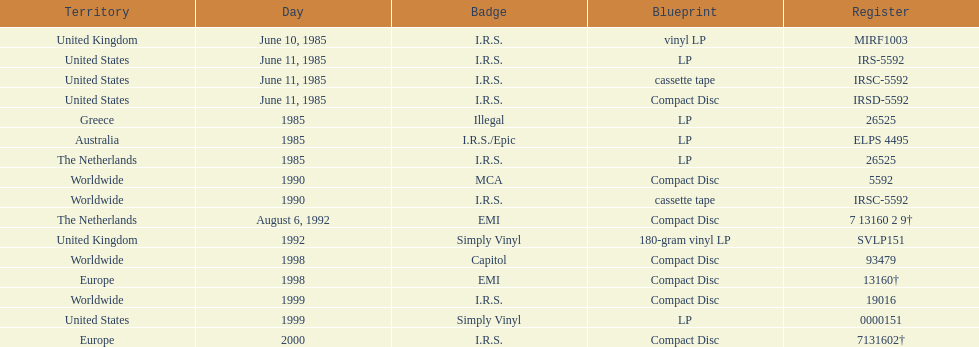Which year had the most releases? 1985. 